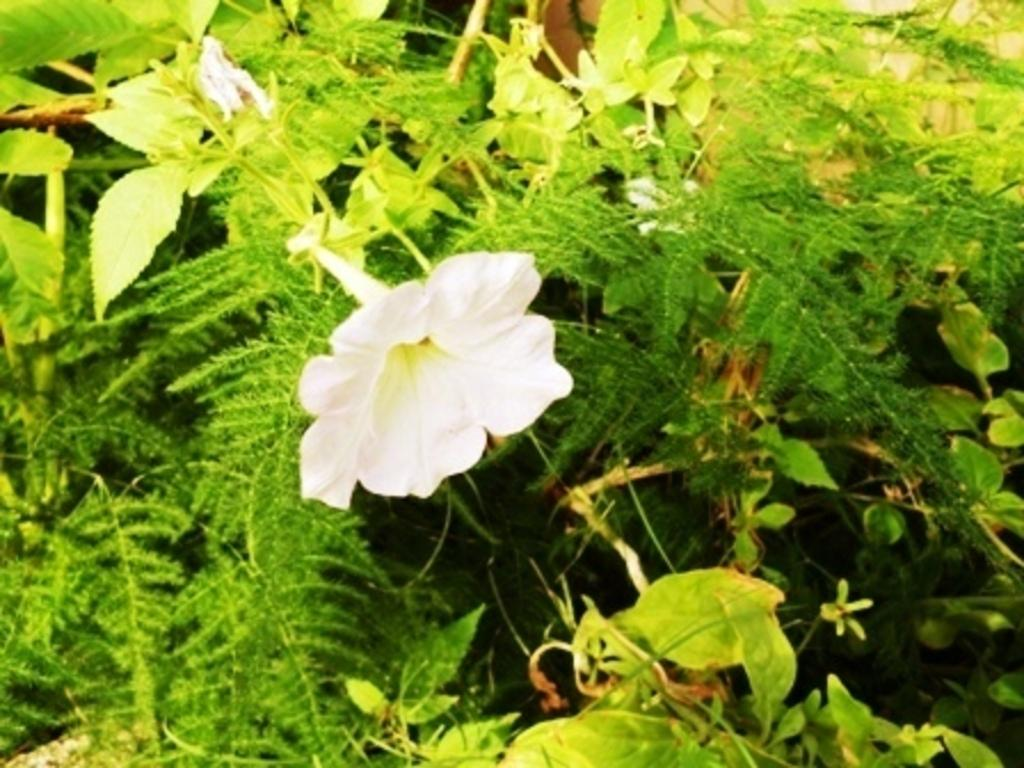What type of living organisms can be seen in the image? Plants can be seen in the image. Can you describe a specific type of flower present in the image? There is a white-colored flower in the image. How does the wealth of the plants in the image contribute to their growth? There is no indication of wealth in the image, and plants do not have wealth. Their growth is determined by factors such as sunlight, water, and soil quality. 